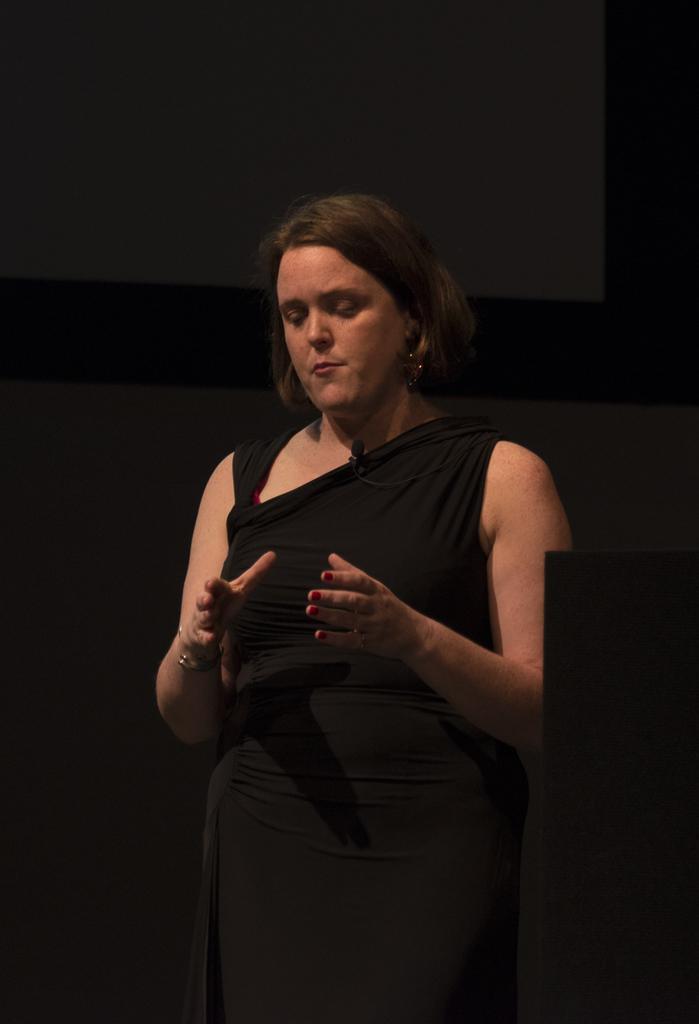In one or two sentences, can you explain what this image depicts? In the center of the image a lady is standing. At the top of the image a board is there. In the middle of the image a wall is present. 